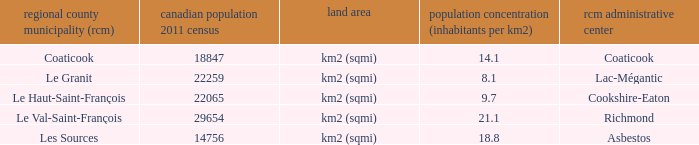What is the seat of the RCM in the county that has a density of 9.7? Cookshire-Eaton. 